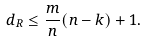<formula> <loc_0><loc_0><loc_500><loc_500>d _ { R } \leq \frac { m } { n } ( n - k ) + 1 .</formula> 